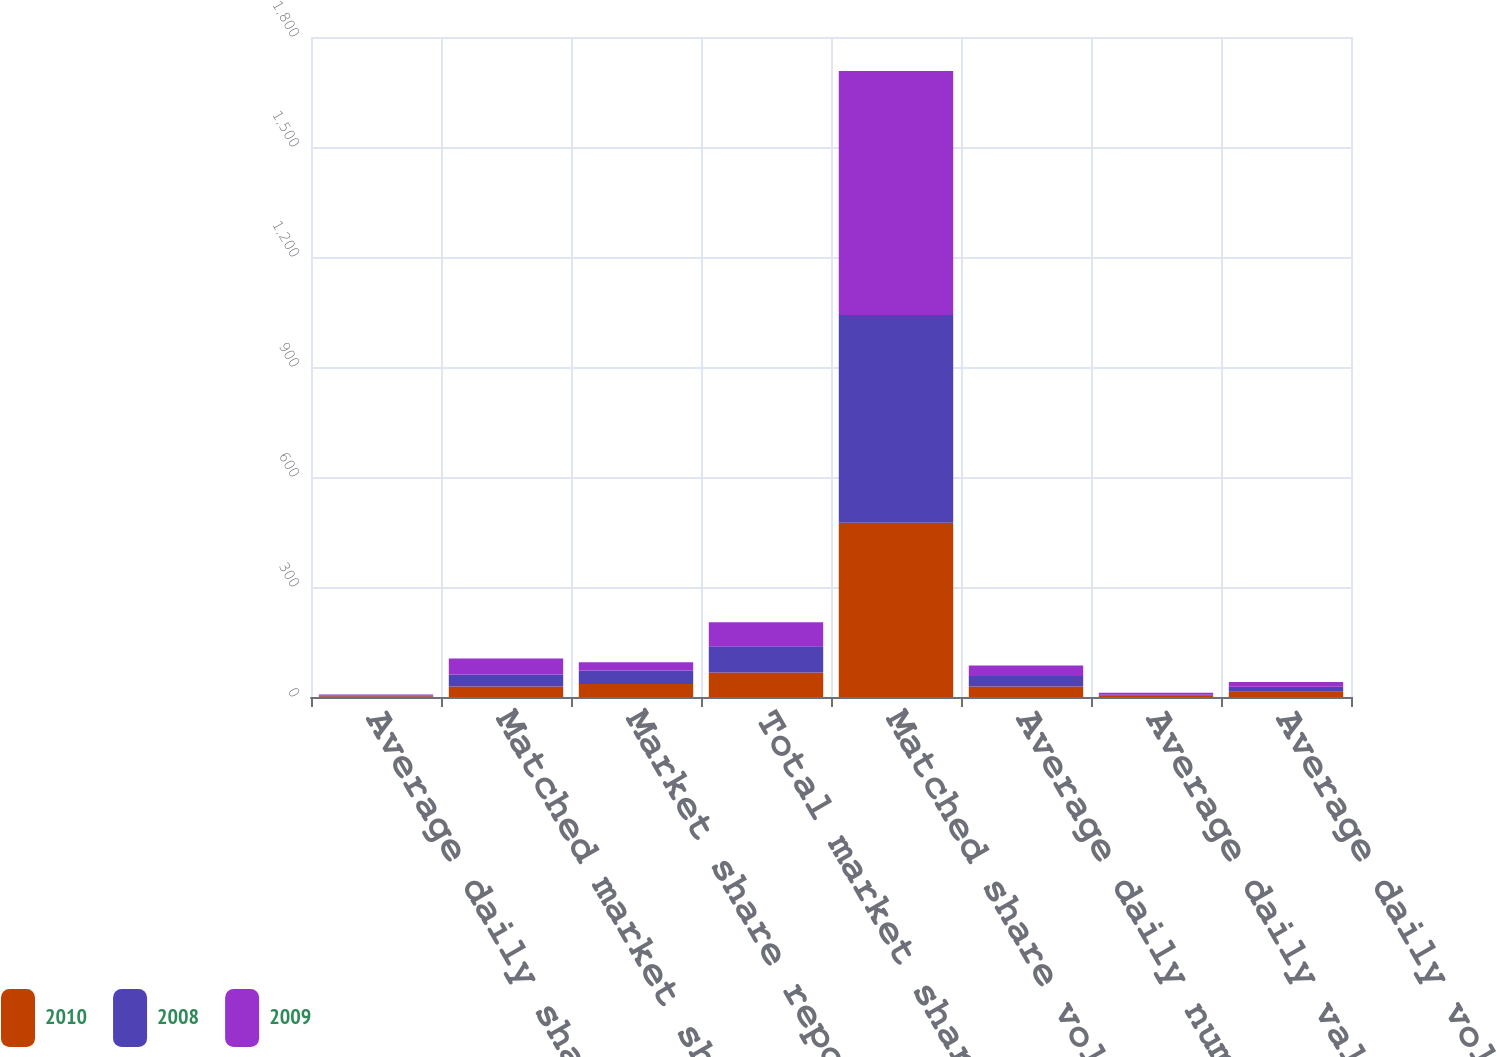Convert chart. <chart><loc_0><loc_0><loc_500><loc_500><stacked_bar_chart><ecel><fcel>Average daily share volume (in<fcel>Matched market share executed<fcel>Market share reported to the<fcel>Total market share (2)<fcel>Matched share volume (in<fcel>Average daily number of equity<fcel>Average daily value of shares<fcel>Average daily volume (in<nl><fcel>2010<fcel>2.19<fcel>28.6<fcel>35.5<fcel>67.1<fcel>475<fcel>28.6<fcel>3.3<fcel>14.3<nl><fcel>2008<fcel>2.24<fcel>33<fcel>36.6<fcel>71<fcel>566.6<fcel>28.6<fcel>3.1<fcel>13.4<nl><fcel>2009<fcel>2.28<fcel>43.2<fcel>22.6<fcel>65.8<fcel>665.9<fcel>28.6<fcel>5<fcel>13<nl></chart> 